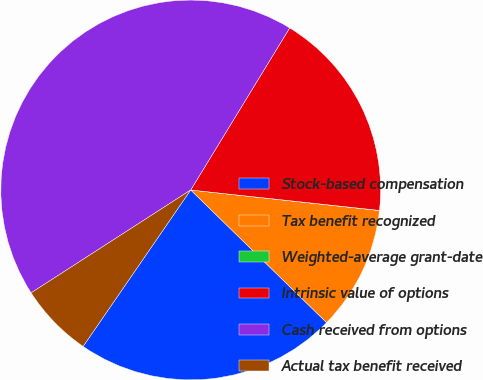<chart> <loc_0><loc_0><loc_500><loc_500><pie_chart><fcel>Stock-based compensation<fcel>Tax benefit recognized<fcel>Weighted-average grant-date<fcel>Intrinsic value of options<fcel>Cash received from options<fcel>Actual tax benefit received<nl><fcel>22.28%<fcel>10.58%<fcel>0.01%<fcel>17.99%<fcel>42.84%<fcel>6.3%<nl></chart> 